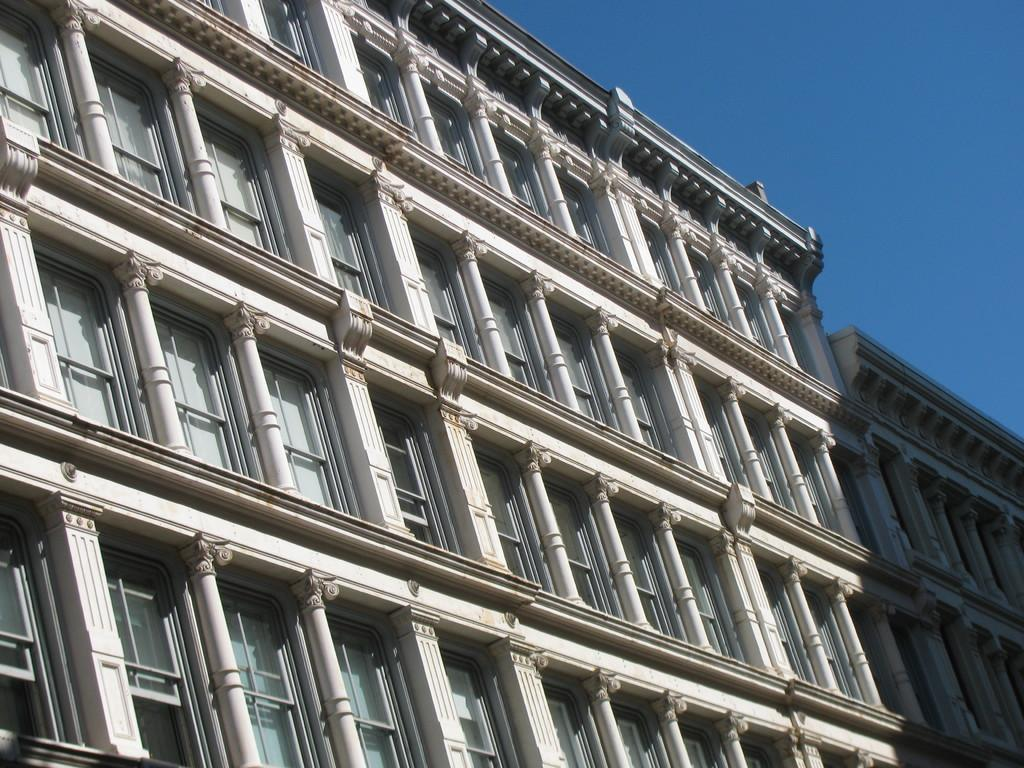What is the main structure in the image? There is a building in the image. What feature of the building can be observed? The building has multiple windows. What can be seen in the background of the image? The sky is visible in the background of the image. What color is the sky in the image? The sky is blue in the image. What type of story is being told by the donkey in the image? There is no donkey present in the image, so no story can be told by a donkey. 